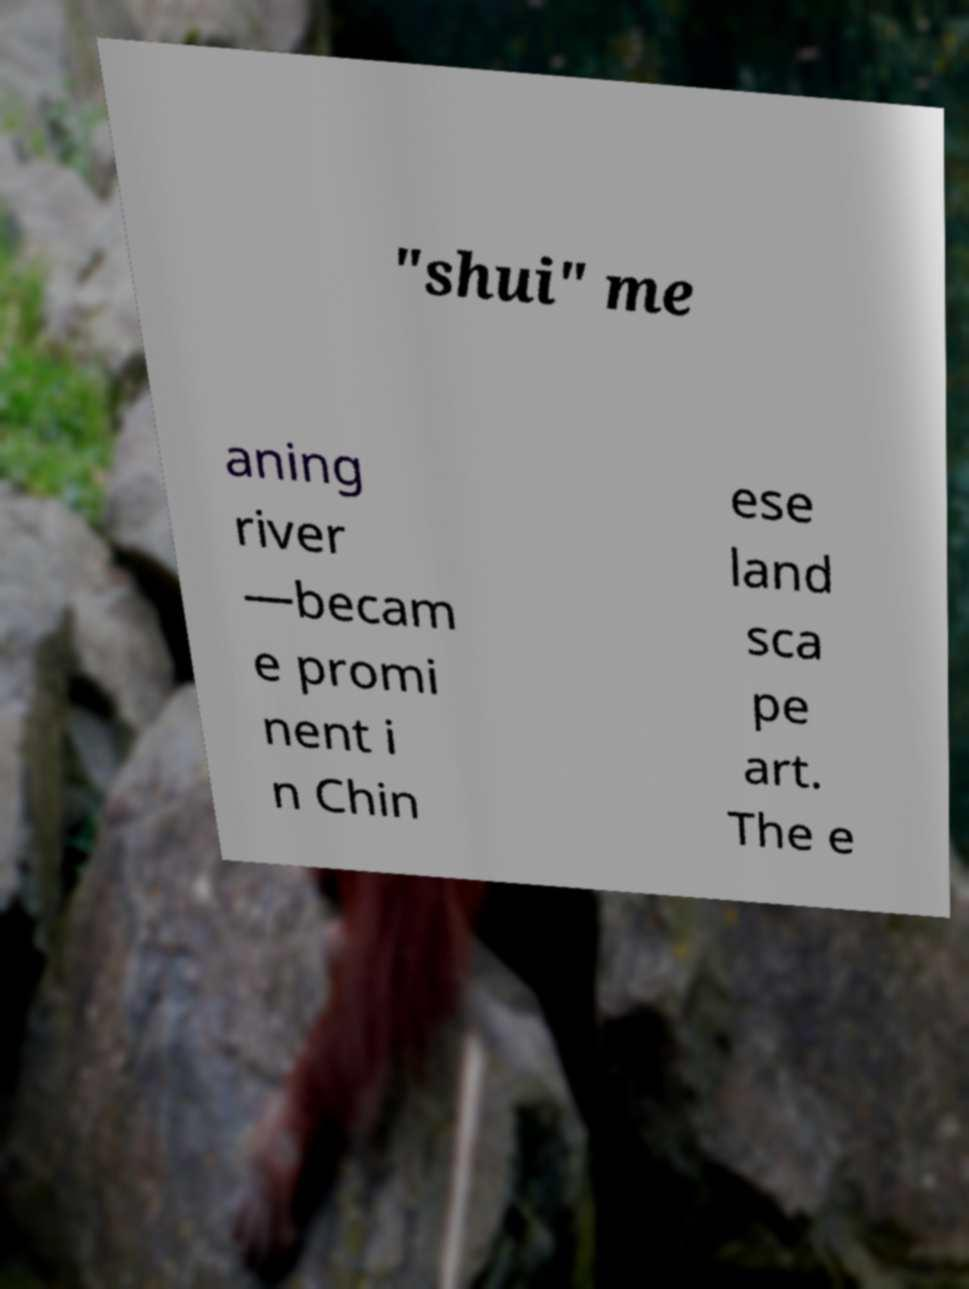Please read and relay the text visible in this image. What does it say? "shui" me aning river —becam e promi nent i n Chin ese land sca pe art. The e 